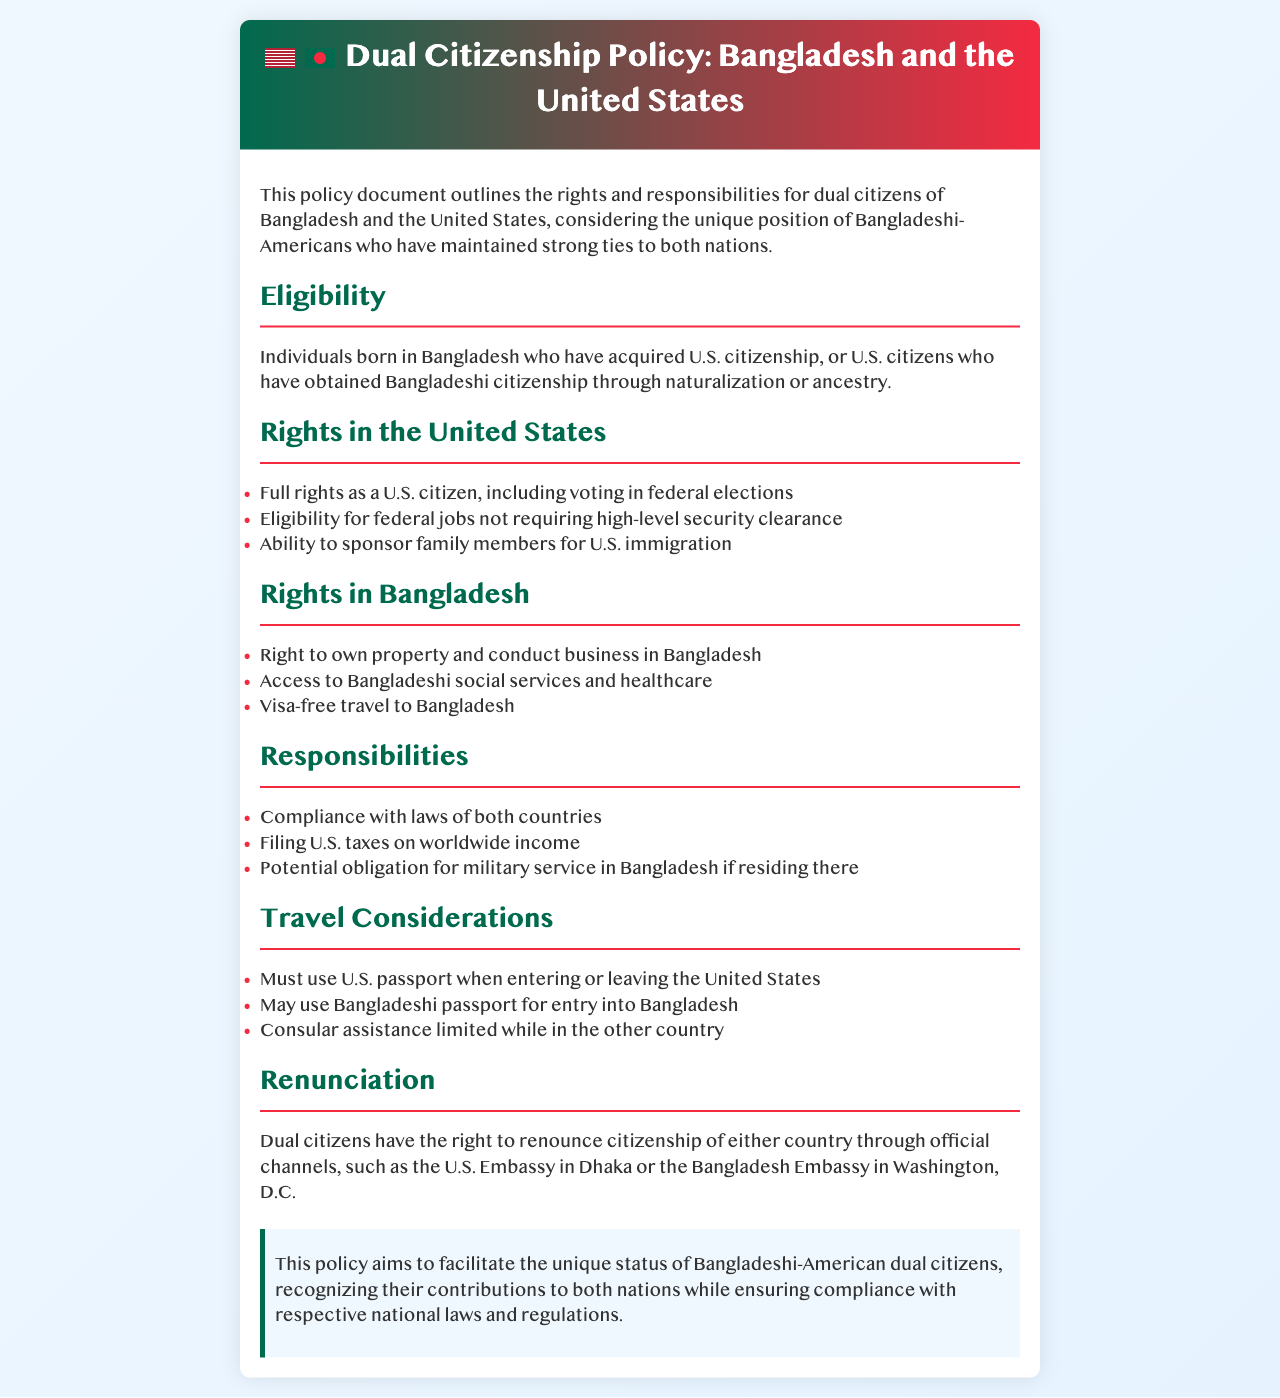What is the eligibility for dual citizenship between Bangladesh and the United States? Eligibility includes individuals born in Bangladesh who have acquired U.S. citizenship or U.S. citizens who have obtained Bangladeshi citizenship through naturalization or ancestry.
Answer: Individuals born in Bangladesh or U.S. citizens with Bangladeshi citizenship What rights do dual citizens have in the United States? Rights in the U.S. include full rights as a citizen, eligibility for certain federal jobs, and the ability to sponsor family members for U.S. immigration.
Answer: Full rights as a U.S. citizen What is one responsibility of dual citizens while residing in the U.S.? One responsibility includes filing U.S. taxes on worldwide income, as stated in the responsibilities section of the document.
Answer: Filing U.S. taxes What passport must dual citizens use when entering the United States? The document specifies that dual citizens must use a U.S. passport when entering or leaving the United States.
Answer: U.S. passport How can dual citizens renounce their citizenship? The document states that dual citizens can renounce citizenship through official channels, such as the U.S. Embassy in Dhaka or the Bangladesh Embassy in Washington, D.C.
Answer: Official channels What social services do dual citizens in Bangladesh have access to? The rights in Bangladesh include access to Bangladeshi social services and healthcare, found in the rights section of the document.
Answer: Social services and healthcare What must dual citizens do regarding the laws of both countries? The responsibilities state that dual citizens must comply with the laws of both countries as a general requirement.
Answer: Compliance with laws What is a potential military obligation for dual citizens? The responsibilities section mentions a potential obligation for military service in Bangladesh if residing there.
Answer: Military service in Bangladesh What benefit do dual citizens have regarding property in Bangladesh? The rights section highlights the right to own property and conduct business in Bangladesh.
Answer: Own property and conduct business 